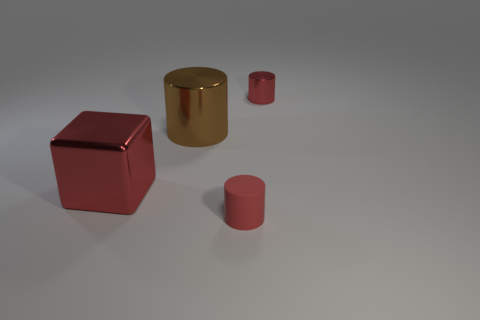Is the big red cube made of the same material as the tiny thing that is on the right side of the small red matte cylinder?
Provide a short and direct response. Yes. Are there any small matte cylinders behind the brown object?
Give a very brief answer. No. How many things are small red metal things or red things that are behind the big metallic block?
Your answer should be compact. 1. What color is the tiny cylinder right of the tiny red cylinder that is left of the small red metal object?
Provide a short and direct response. Red. How many other things are there of the same material as the large red thing?
Offer a very short reply. 2. What number of metal objects are large brown objects or red cylinders?
Provide a short and direct response. 2. There is another tiny thing that is the same shape as the tiny metal thing; what color is it?
Your answer should be very brief. Red. What number of things are tiny red cylinders or red shiny objects?
Keep it short and to the point. 3. The large brown thing that is made of the same material as the big block is what shape?
Provide a short and direct response. Cylinder. How many tiny things are red cylinders or metallic cylinders?
Make the answer very short. 2. 